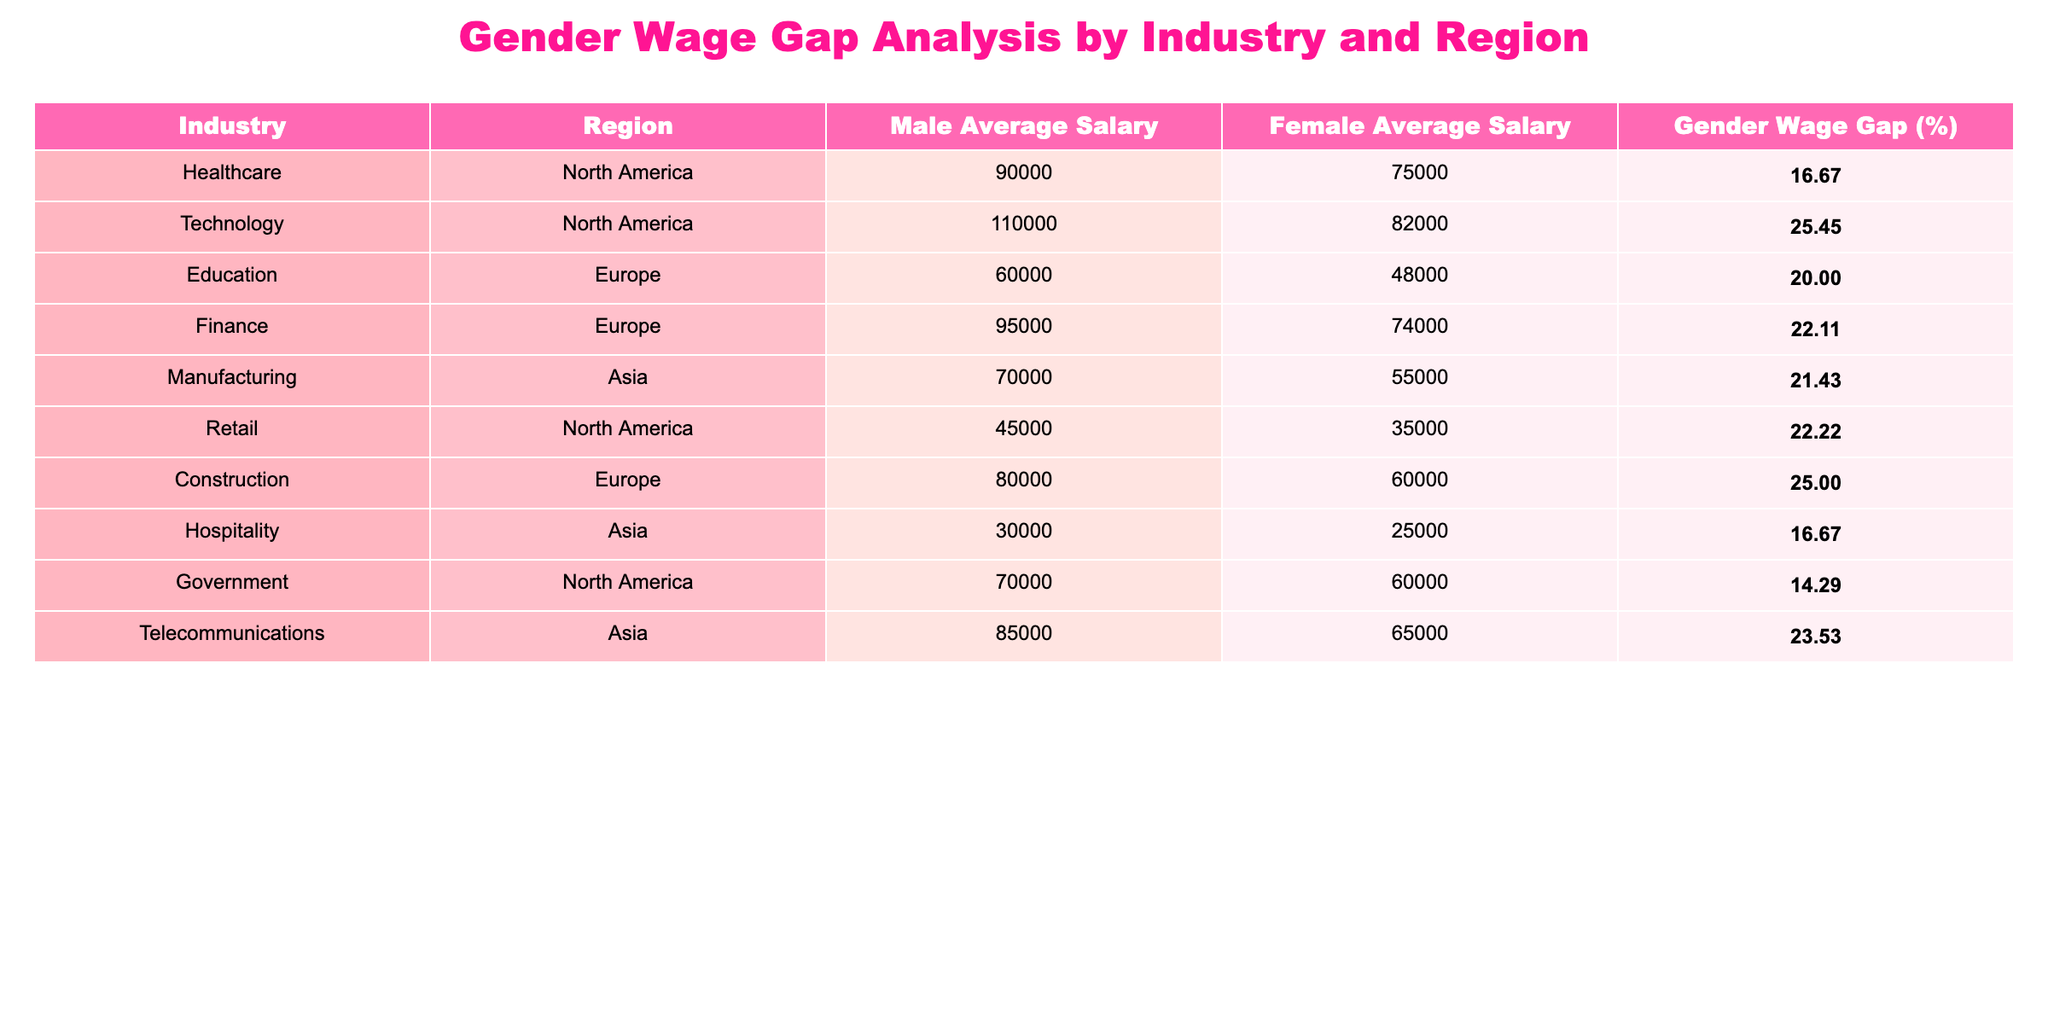What is the average male salary in the Technology industry? The male average salary for the Technology industry is listed in the table, which shows a value of 110000.
Answer: 110000 Which industry has the highest gender wage gap in North America? By comparing the gender wage gap percentages for North American industries, Technology shows a gap of 25.45%, which is the highest.
Answer: Technology Is the gender wage gap in the Healthcare industry higher than in the Government sector? The gender wage gap in Healthcare is 16.67%, while the Government sector has a gap of 14.29%. Since 16.67% is greater than 14.29%, the statement is true.
Answer: Yes What is the difference in average salaries between males and females in the Finance industry? The male average salary in Finance is 95000 and the female average salary is 74000. The difference is 95000 - 74000 = 21000.
Answer: 21000 Which region has the lowest average salary for females based on the table? The table shows that the average female salary in the Hospitality sector (Asia) is the lowest at 25000.
Answer: Asia (Hospitality) Calculate the overall average gender wage gap across all sectors in the table. First, sum the gender wage gap percentages: 16.67 + 25.45 + 20.00 + 22.11 + 21.43 + 22.22 + 25.00 + 16.67 + 14.29 + 23.53 =  217.37. Then divide by the number of sectors (10) to get the average: 217.37 / 10 = 21.74.
Answer: 21.74 Are females in the Education sector earning more than those in the Retail sector? The average female salary in Education is 48000, whereas in Retail, it is only 35000. Since 48000 is greater than 35000, the statement is true.
Answer: Yes How much more do males earn on average than females in the Manufacturing industry? The average male salary in Manufacturing is 70000, and the female average is 55000. The difference is 70000 - 55000 = 15000.
Answer: 15000 Which industry shows the least gender wage gap? The industry with the least gender wage gap listed is Government in North America, with a gap of 14.29%.
Answer: Government In which industry is the female average salary the highest? By looking at the female average salaries, the highest value is in Healthcare, where the salary is 75000.
Answer: Healthcare 